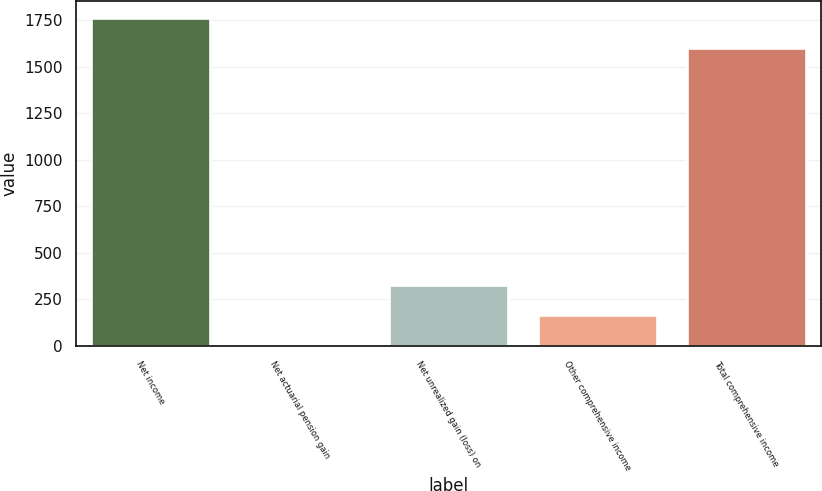Convert chart. <chart><loc_0><loc_0><loc_500><loc_500><bar_chart><fcel>Net income<fcel>Net actuarial pension gain<fcel>Net unrealized gain (loss) on<fcel>Other comprehensive income<fcel>Total comprehensive income<nl><fcel>1762.9<fcel>3<fcel>324.8<fcel>163.9<fcel>1602<nl></chart> 